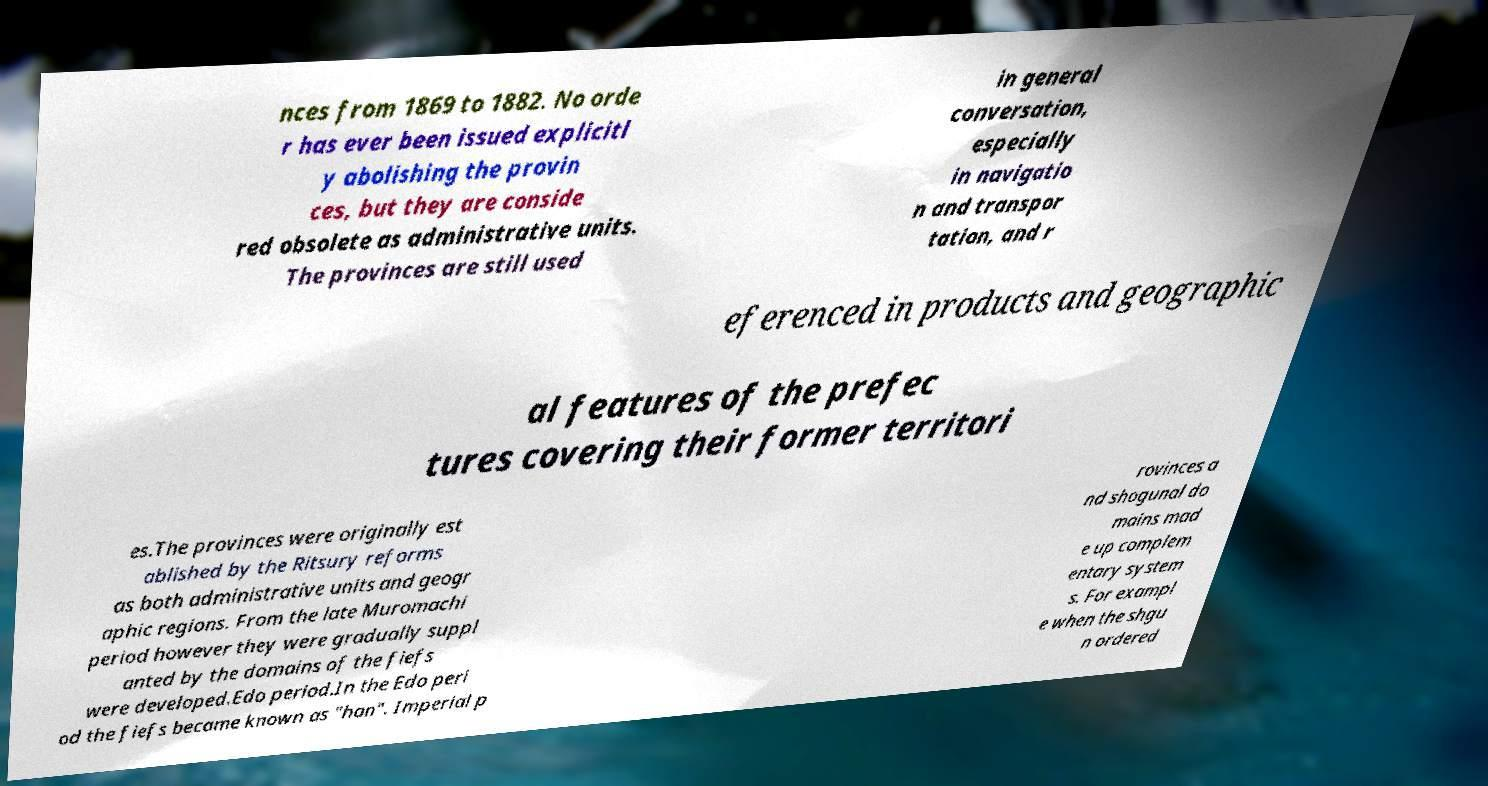Could you assist in decoding the text presented in this image and type it out clearly? nces from 1869 to 1882. No orde r has ever been issued explicitl y abolishing the provin ces, but they are conside red obsolete as administrative units. The provinces are still used in general conversation, especially in navigatio n and transpor tation, and r eferenced in products and geographic al features of the prefec tures covering their former territori es.The provinces were originally est ablished by the Ritsury reforms as both administrative units and geogr aphic regions. From the late Muromachi period however they were gradually suppl anted by the domains of the fiefs were developed.Edo period.In the Edo peri od the fiefs became known as "han". Imperial p rovinces a nd shogunal do mains mad e up complem entary system s. For exampl e when the shgu n ordered 